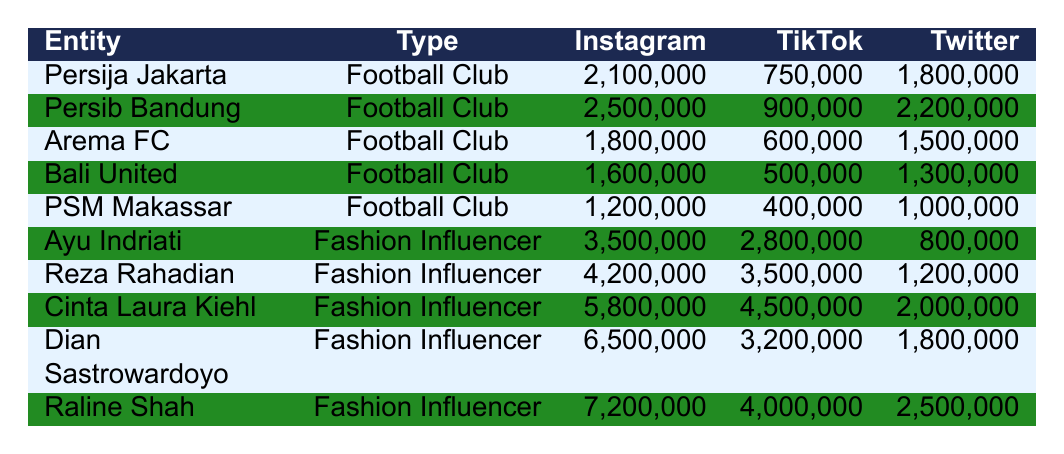What is the total number of Instagram followers for all the football clubs listed? The football clubs listed are Persija Jakarta, Persib Bandung, Arema FC, Bali United, and PSM Makassar. Their Instagram followers are 2,100,000, 2,500,000, 1,800,000, 1,600,000, and 1,200,000 respectively. Adding these values gives a total of (2,100,000 + 2,500,000 + 1,800,000 + 1,600,000 + 1,200,000) = 9,200,000.
Answer: 9,200,000 Which fashion influencer has the most TikTok followers? By examining the TikTok follower counts, Ayu Indriati has 2,800,000, Reza Rahadian has 3,500,000, Cinta Laura Kiehl has 4,500,000, Dian Sastrowardoyo has 3,200,000, and Raline Shah has 4,000,000. The highest value is 4,500,000 for Cinta Laura Kiehl.
Answer: Cinta Laura Kiehl Is it true that Bali United has more Twitter followers than PSM Makassar? Bali United has 1,300,000 Twitter followers while PSM Makassar has 1,000,000. Since 1,300,000 is greater than 1,000,000, the statement is true.
Answer: Yes What is the average number of Instagram followers for the fashion influencers? The Instagram followers for the fashion influencers are 3,500,000, 4,200,000, 5,800,000, 6,500,000, and 7,200,000. The total is (3,500,000 + 4,200,000 + 5,800,000 + 6,500,000 + 7,200,000) = 27,200,000. There are 5 fashion influencers, so the average is 27,200,000 / 5 = 5,440,000.
Answer: 5,440,000 Which entity has the highest combined followers across all platforms? To find the highest combined followers, add each entity's followers: Persija Jakarta (4,650,000), Persib Bandung (5,400,000), Arema FC (3,300,000), Bali United (2,400,000), PSM Makassar (2,600,000), Ayu Indriati (6,680,000), Reza Rahadian (8,920,000), Cinta Laura Kiehl (12,300,000), Dian Sastrowardoyo (11,500,000), Raline Shah (13,700,000). The highest combined value is for Raline Shah at 13,700,000.
Answer: Raline Shah What is the difference in Twitter followers between the club with the most followers and the club with the least followers? The football clubs with the most Twitter followers are Persib Bandung with 2,200,000 and the club with the least is PSM Makassar with 1,000,000. The difference is (2,200,000 - 1,000,000) = 1,200,000.
Answer: 1,200,000 Who has more followers overall, Persib Bandung or Reza Rahadian? To find the overall followers, add Persib Bandung's followers: Instagram (2,500,000) + TikTok (900,000) + Twitter (2,200,000) = 5,600,000. For Reza Rahadian: Instagram (4,200,000) + TikTok (3,500,000) + Twitter (1,200,000) = 8,900,000. Comparing the overall numbers shows that Reza Rahadian has more followers.
Answer: Reza Rahadian Which influencer has a lower TikTok following, Cinta Laura Kiehl or Dian Sastrowardoyo? Cinta Laura Kiehl has 4,500,000 TikTok followers while Dian Sastrowardoyo has 3,200,000. Since 3,200,000 is less than 4,500,000, Dian Sastrowardoyo has a lower following.
Answer: Dian Sastrowardoyo How many Instagram followers do all the listed entities have combined? Sum the Instagram followers for all entries: 2,100,000 (Persija Jakarta) + 2,500,000 (Persib Bandung) + 1,800,000 (Arema FC) + 1,600,000 (Bali United) + 1,200,000 (PSM Makassar) + 3,500,000 (Ayu Indriati) + 4,200,000 (Reza Rahadian) + 5,800,000 (Cinta Laura Kiehl) + 6,500,000 (Dian Sastrowardoyo) + 7,200,000 (Raline Shah) gives a total of 36,400,000.
Answer: 36,400,000 